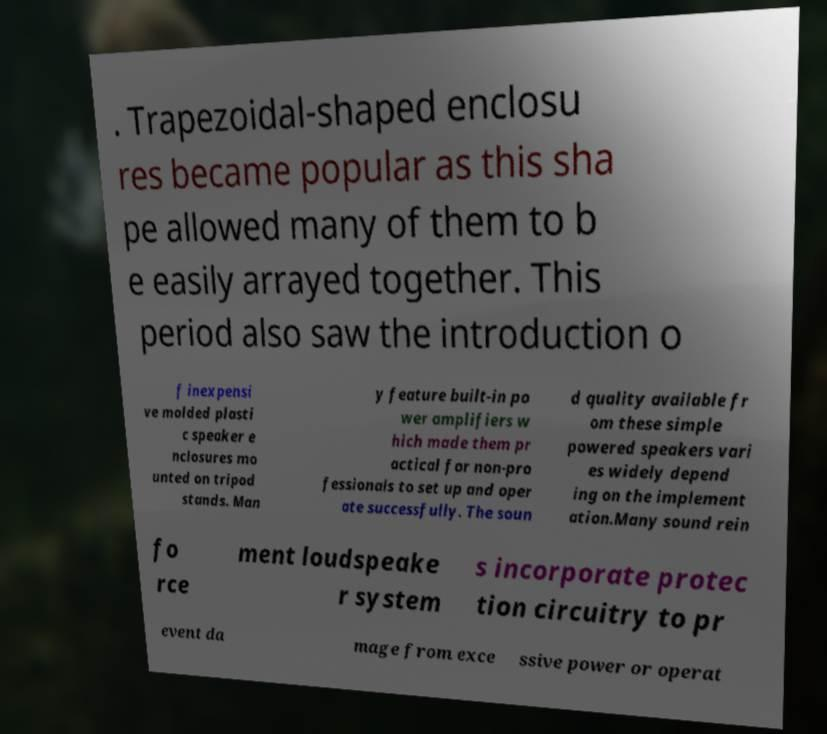Could you extract and type out the text from this image? . Trapezoidal-shaped enclosu res became popular as this sha pe allowed many of them to b e easily arrayed together. This period also saw the introduction o f inexpensi ve molded plasti c speaker e nclosures mo unted on tripod stands. Man y feature built-in po wer amplifiers w hich made them pr actical for non-pro fessionals to set up and oper ate successfully. The soun d quality available fr om these simple powered speakers vari es widely depend ing on the implement ation.Many sound rein fo rce ment loudspeake r system s incorporate protec tion circuitry to pr event da mage from exce ssive power or operat 